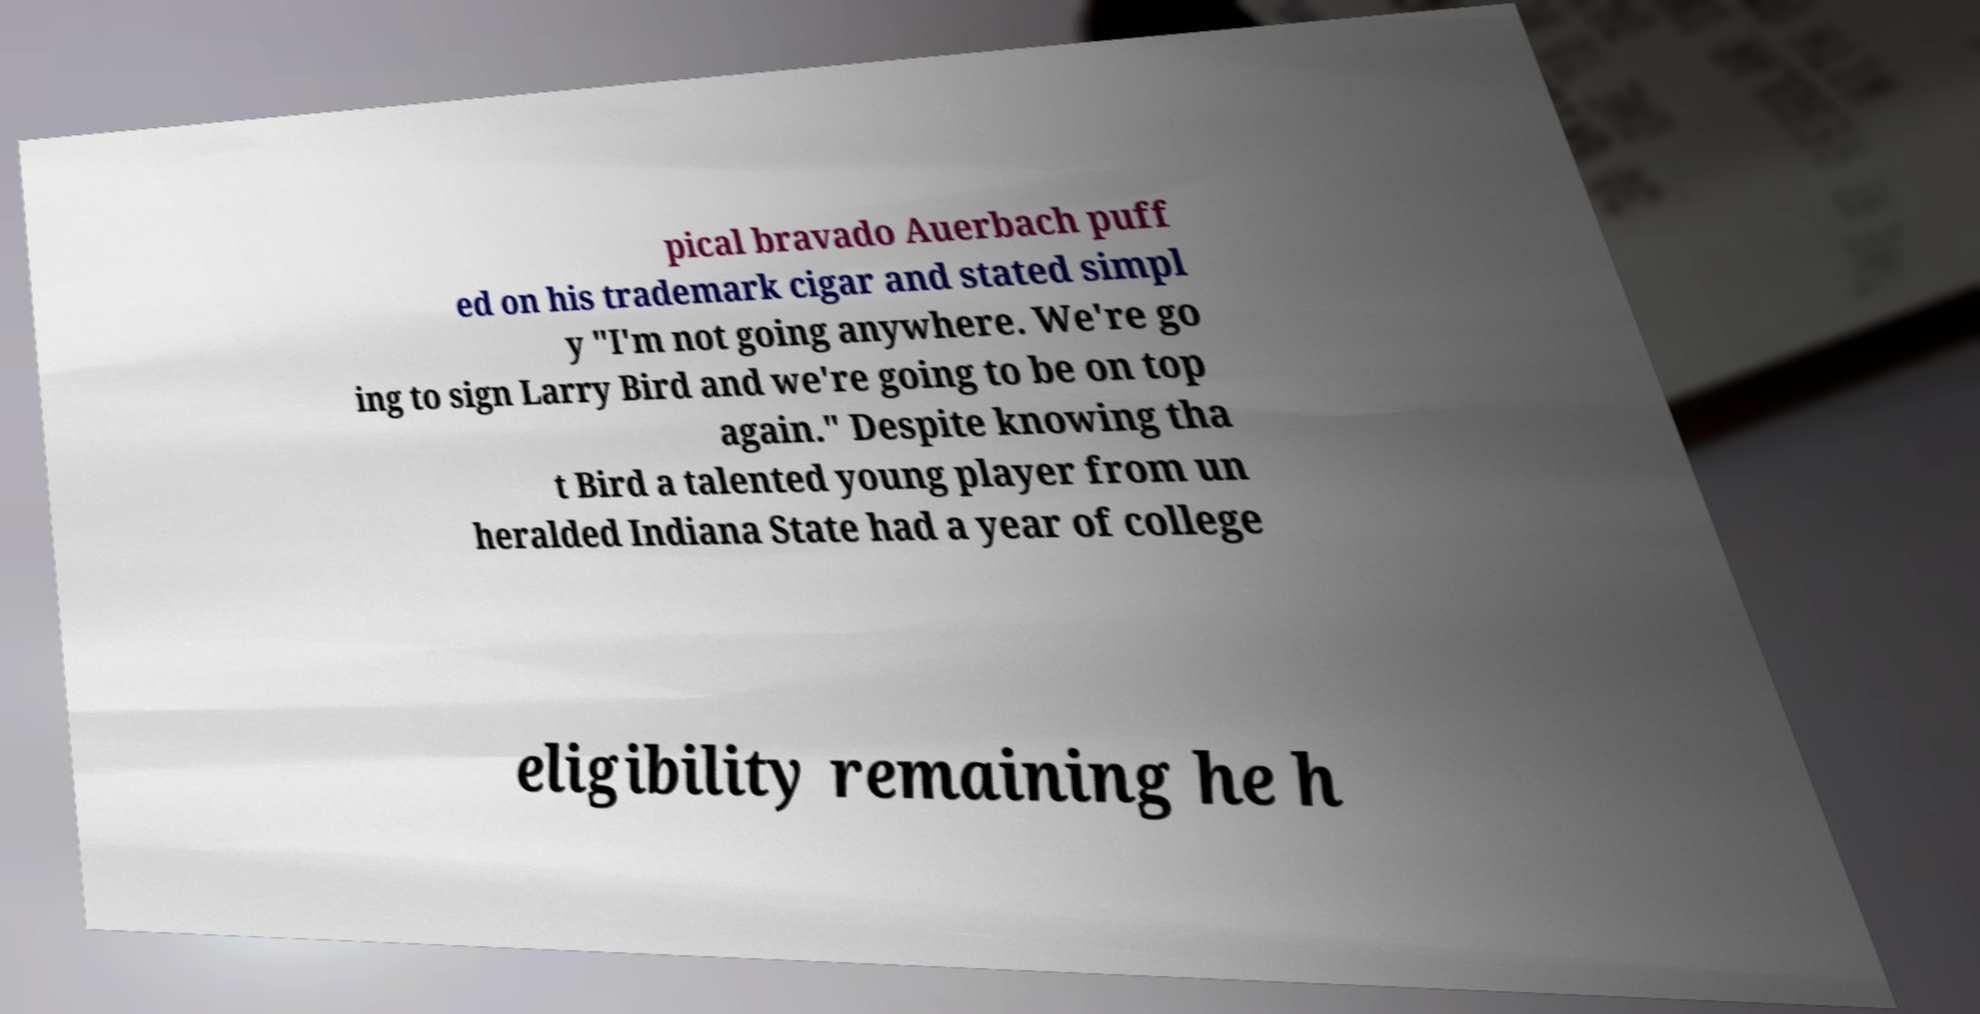What messages or text are displayed in this image? I need them in a readable, typed format. pical bravado Auerbach puff ed on his trademark cigar and stated simpl y "I'm not going anywhere. We're go ing to sign Larry Bird and we're going to be on top again." Despite knowing tha t Bird a talented young player from un heralded Indiana State had a year of college eligibility remaining he h 